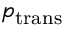Convert formula to latex. <formula><loc_0><loc_0><loc_500><loc_500>p _ { t r a n s }</formula> 